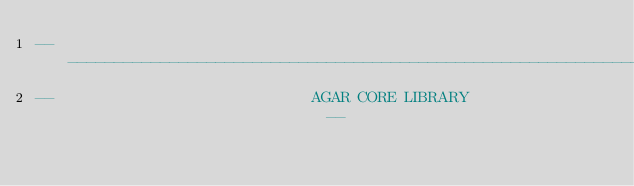<code> <loc_0><loc_0><loc_500><loc_500><_Ada_>------------------------------------------------------------------------------
--                            AGAR CORE LIBRARY                             --</code> 